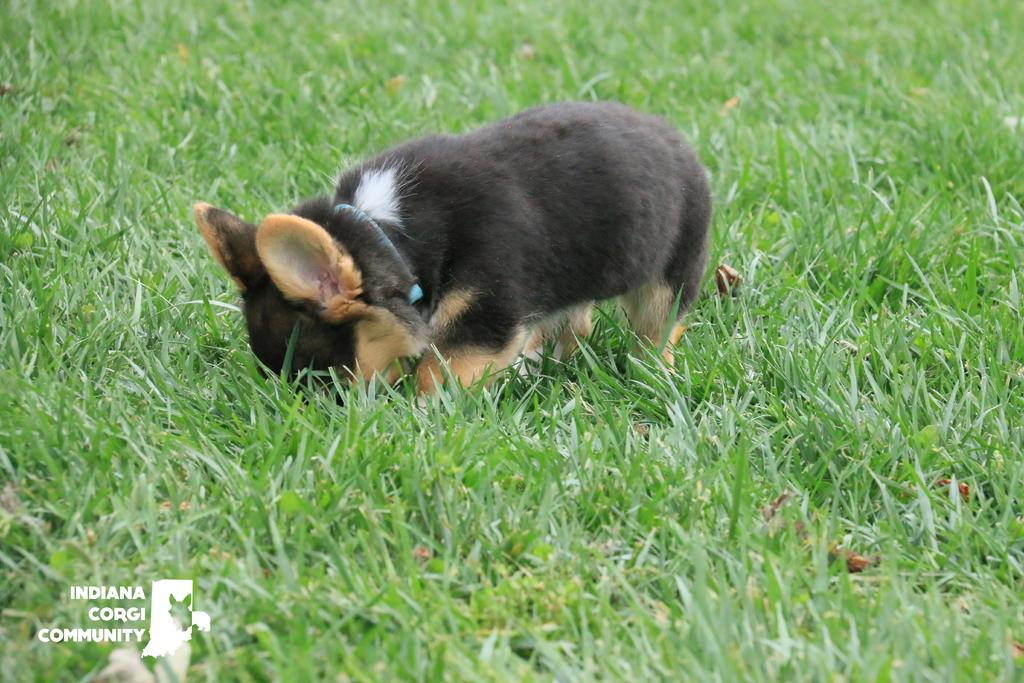What animal is present in the image? There is a dog in the image. What is the dog standing on? The dog is standing on the grass. What type of tooth can be seen in the image? There is no tooth present in the image; it features a dog standing on the grass. 